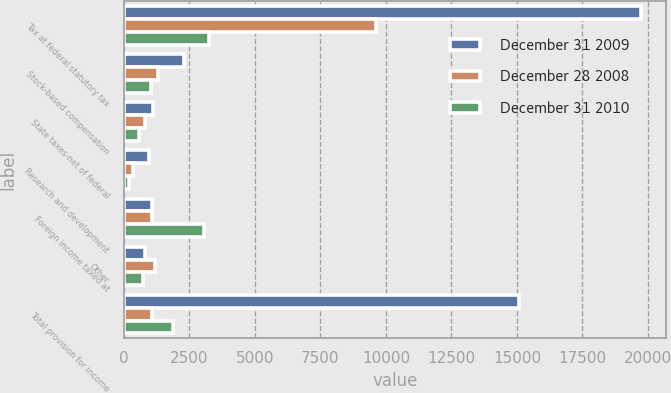Convert chart to OTSL. <chart><loc_0><loc_0><loc_500><loc_500><stacked_bar_chart><ecel><fcel>Tax at federal statutory tax<fcel>Stock-based compensation<fcel>State taxes-net of federal<fcel>Research and development<fcel>Foreign income taxed at<fcel>Other<fcel>Total provision for income<nl><fcel>December 31 2009<fcel>19719<fcel>2308<fcel>1098<fcel>948<fcel>1066<fcel>797<fcel>15096<nl><fcel>December 28 2008<fcel>9629<fcel>1311<fcel>821<fcel>356<fcel>1064<fcel>1202<fcel>1082<nl><fcel>December 31 2010<fcel>3237<fcel>1049<fcel>573<fcel>199<fcel>3047<fcel>721<fcel>1888<nl></chart> 